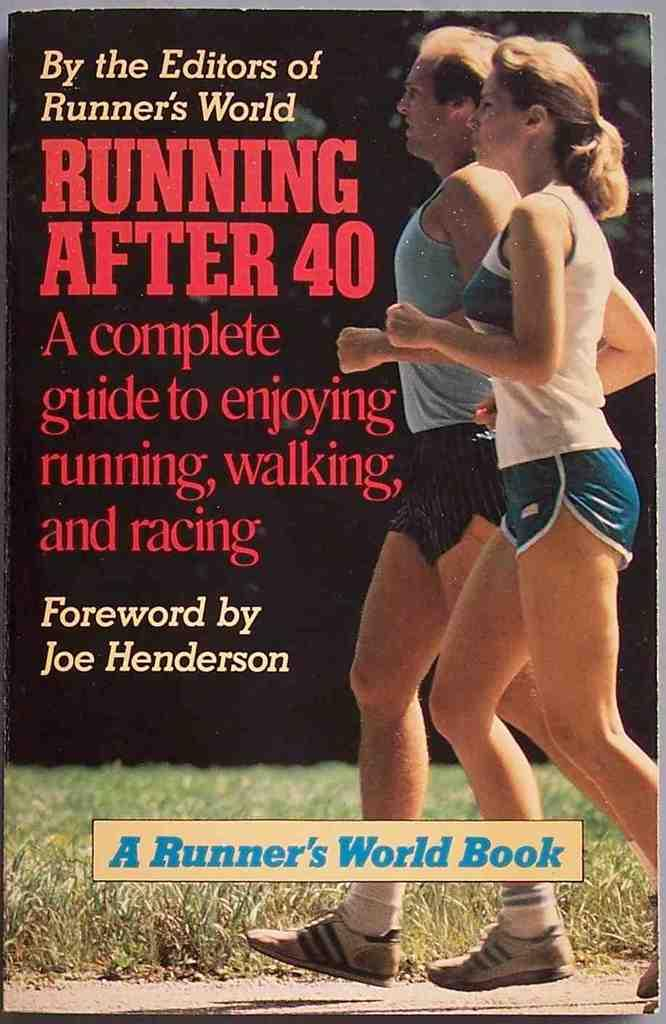<image>
Summarize the visual content of the image. The cover of the book titled Running after forty by Joe Henderson. 